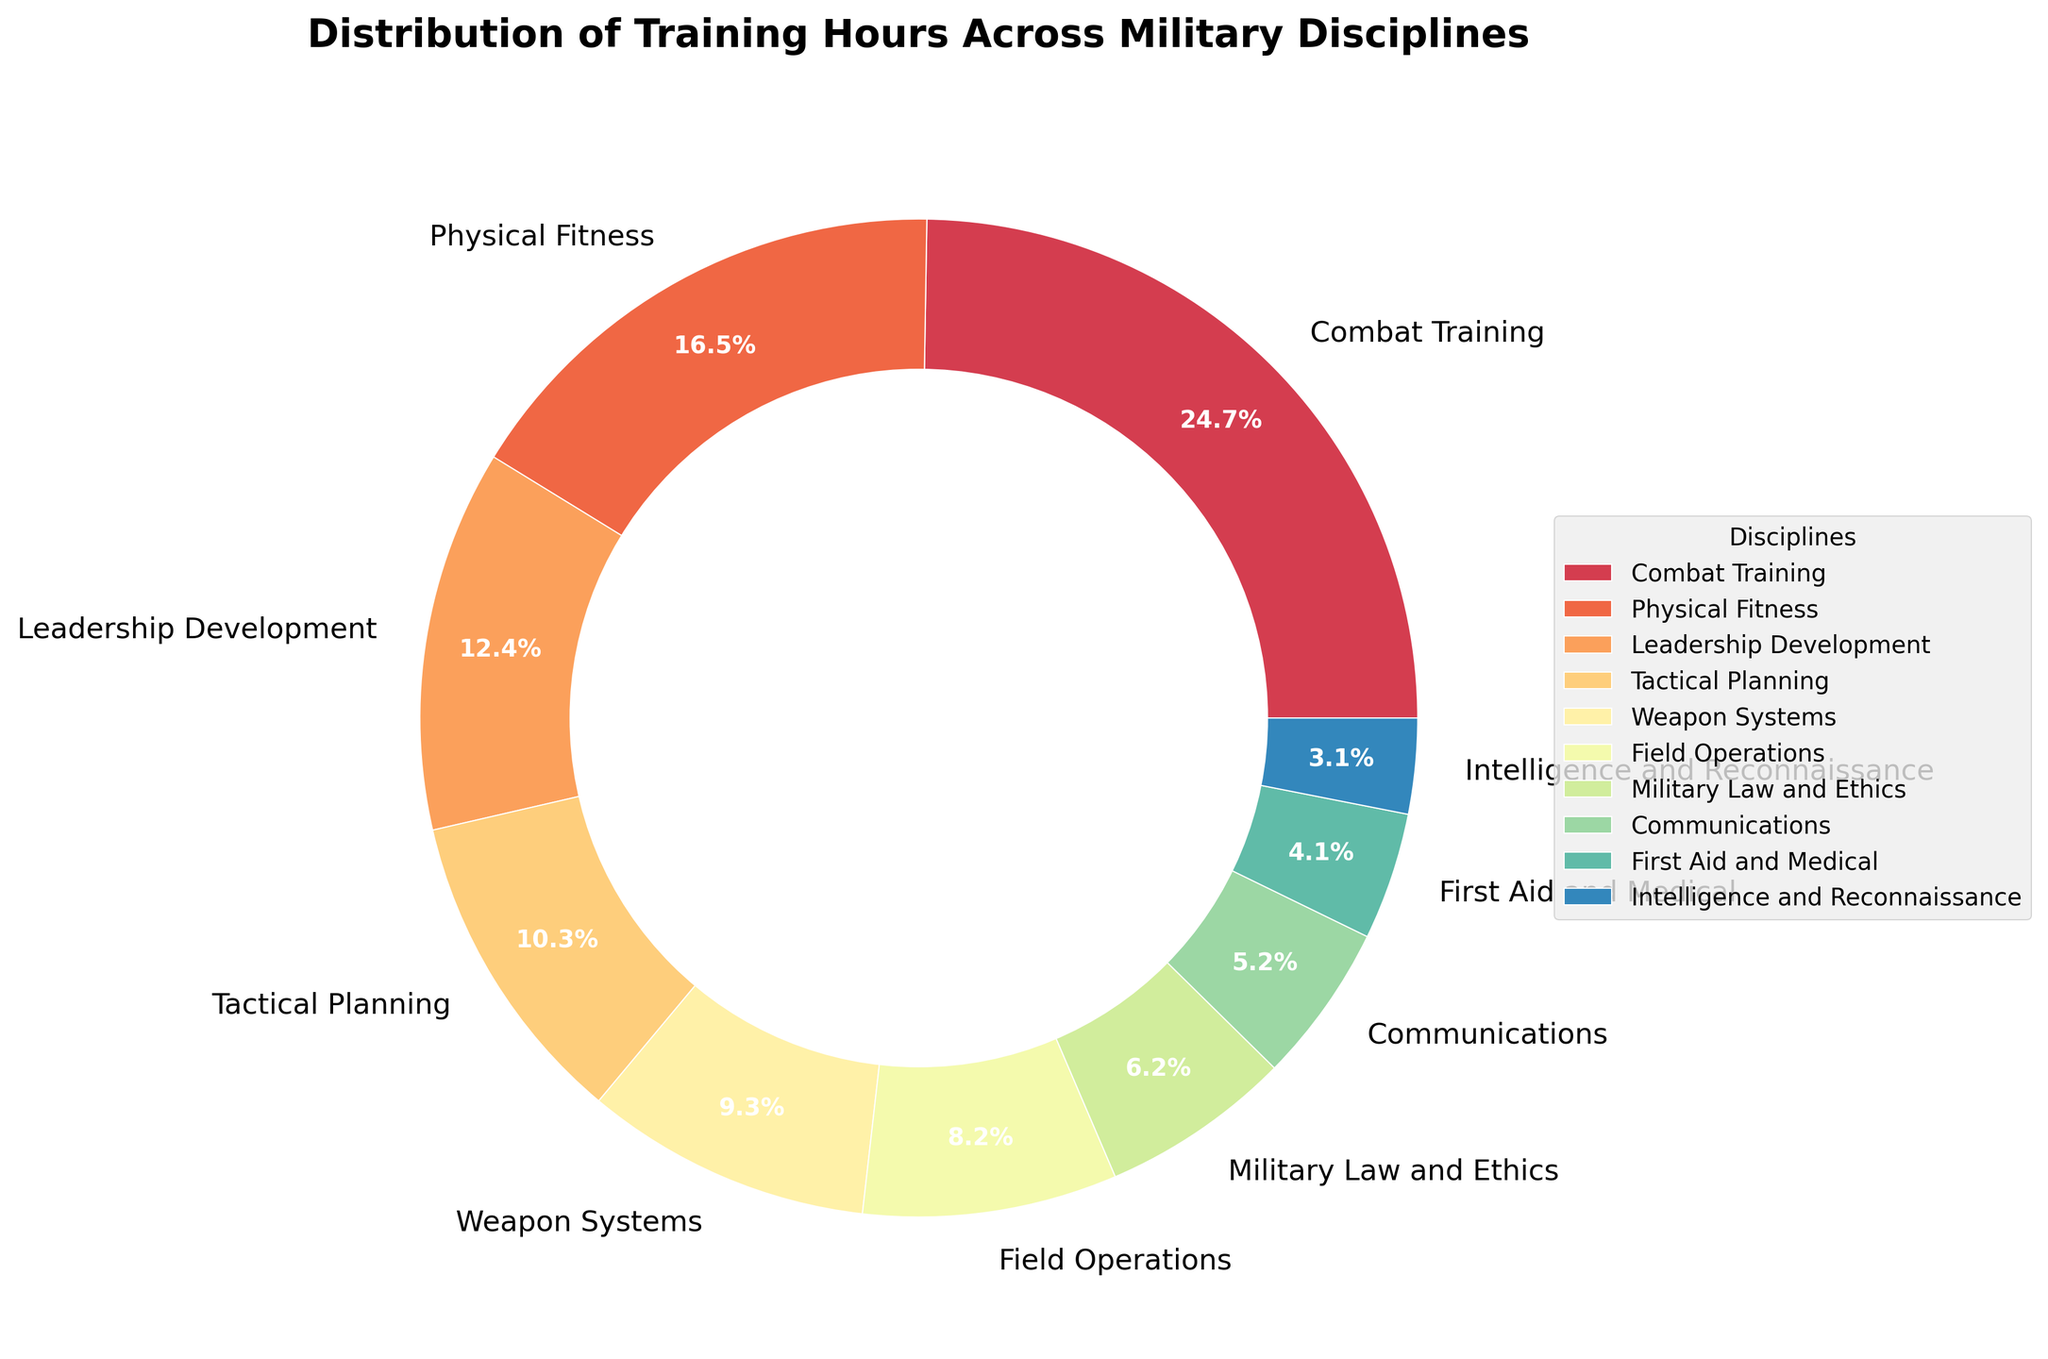What percentage of the total training hours does Combat Training comprise? Identify Combat Training's percentage from the pie chart which shows each discipline's percentage.
Answer: 32.0% Which discipline has the least amount of training hours? The pie chart shows percentages for each discipline. The smallest percentage corresponds to Intelligence and Reconnaissance.
Answer: Intelligence and Reconnaissance How much more time is spent on Combat Training compared to First Aid and Medical training hours? Combat Training is 120 hours and First Aid and Medical is 20 hours. The difference is 120 - 20 = 100 hours.
Answer: 100 hours What's the combined percentage of time spent on Leadership Development and Tactical Planning? Add the percentages for Leadership Development (16%) and Tactical Planning (14%). The sum is 16% + 14% = 30%.
Answer: 30% Which discipline has a larger proportion of training hours, Weapon Systems or Field Operations? Compare the percentages for Weapon Systems (12%) and Field Operations (11%). Weapon Systems has a slightly larger proportion.
Answer: Weapon Systems What is the visual difference in the wedges for Combat Training and Communications in terms of color and size? Combat Training is represented by the largest wedge (32%) and its color is more reddish. Communications has a smaller wedge (6.7%) and its color is towards the greenish-blue spectrum.
Answer: Combat Training: largest reddish, Communications: smaller greenish-blue How does the time spent on Physical Fitness compare to the combined time of Military Law and Ethics and Communications? Physical Fitness is 80 hours. Combined hours for Military Law and Ethics (30) and Communications (25) is 30 + 25 = 55 hours. 80 hours is more than 55 hours.
Answer: More If we group Tactical Planning, Weapon Systems, and Field Operations together, what percentage of the total training does this new group account for? Add percentages for Tactical Planning (13.3%), Weapon Systems (12%), and Field Operations (10.7%). The total is 13.3% + 12% + 10.7% = 36%.
Answer: 36% What can be inferred about the emphasis of training in Combat Training relative to Intelligence and Reconnaissance? Combat Training takes up 32.0% of the training hours indicating a significant emphasis, while Intelligence and Reconnaissance has only 4%, showing much less emphasis.
Answer: Combat Training has stronger emphasis Which two disciplines combined have nearly the same percentage as Combat Training? Leadership Development (16%) and Physical Fitness (21.3%) combined make 16% + 21.3% ≈ 37.3%. This is closest to the percentage for Combat Training (32.0%) among available combinations.
Answer: Leadership Development and Physical Fitness 